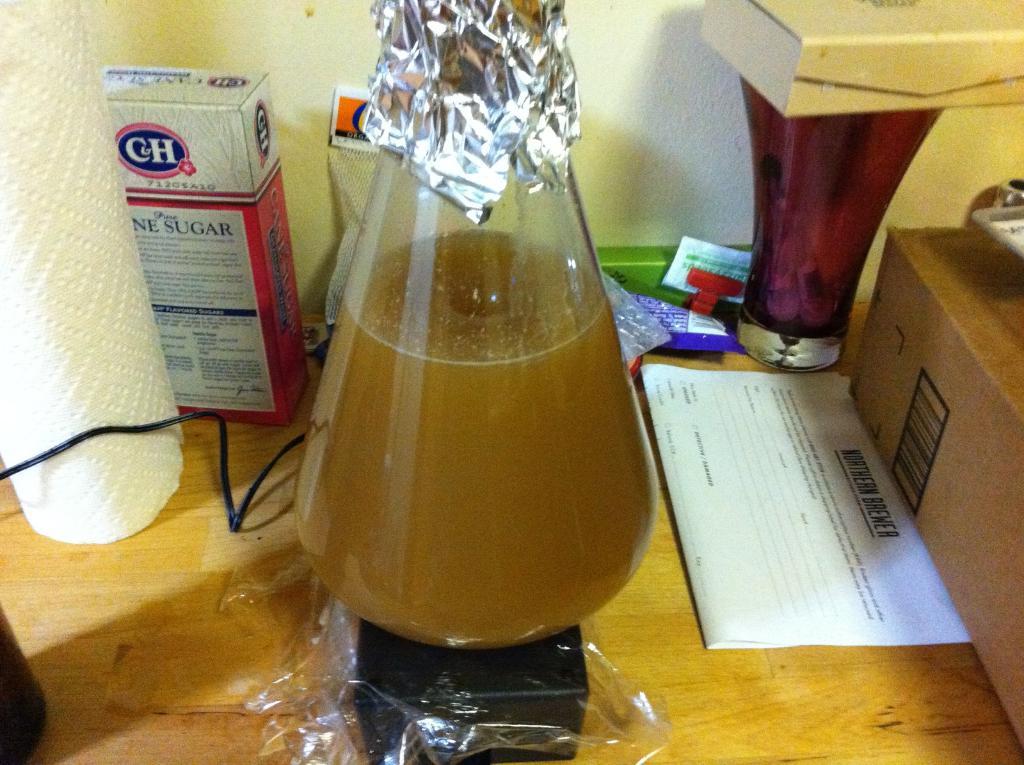Which brewer is mentioned on the white paper?
Ensure brevity in your answer.  Unanswerable. 